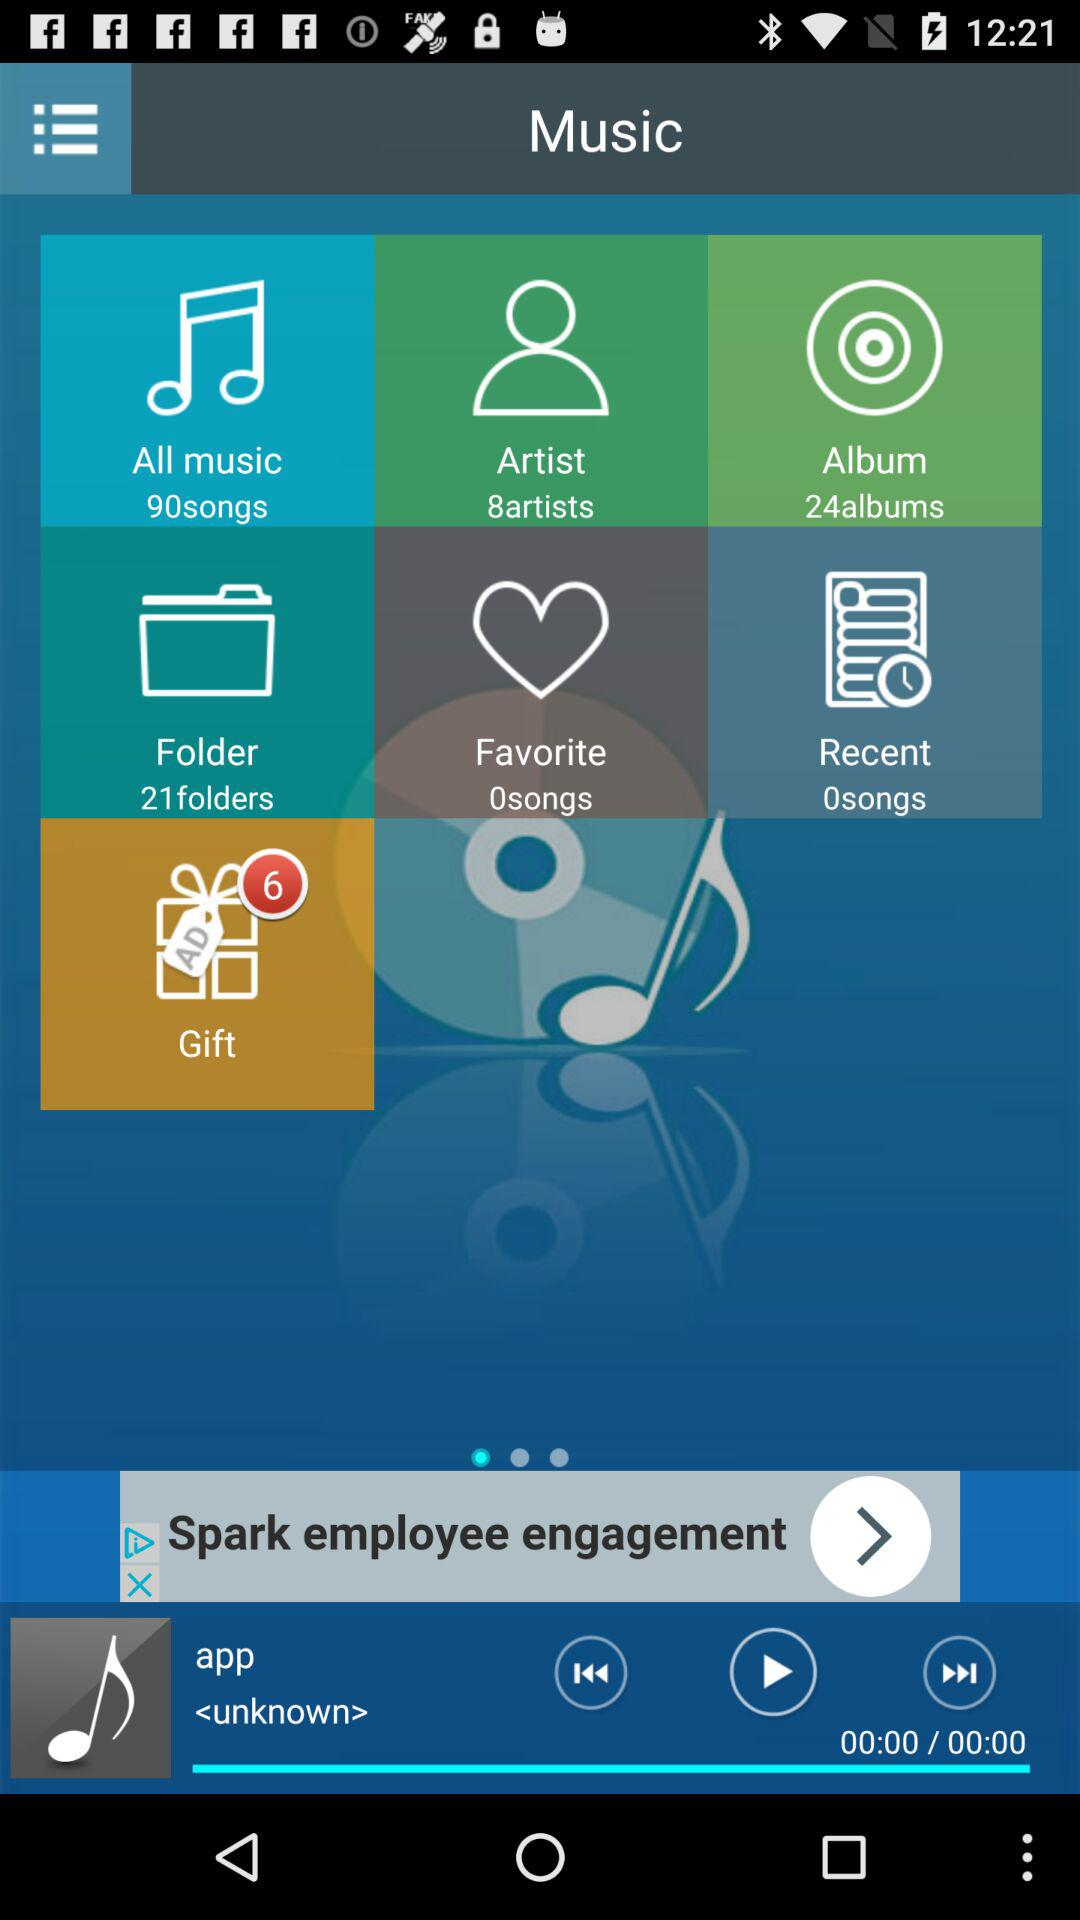How many more albums are there than folders?
Answer the question using a single word or phrase. 3 